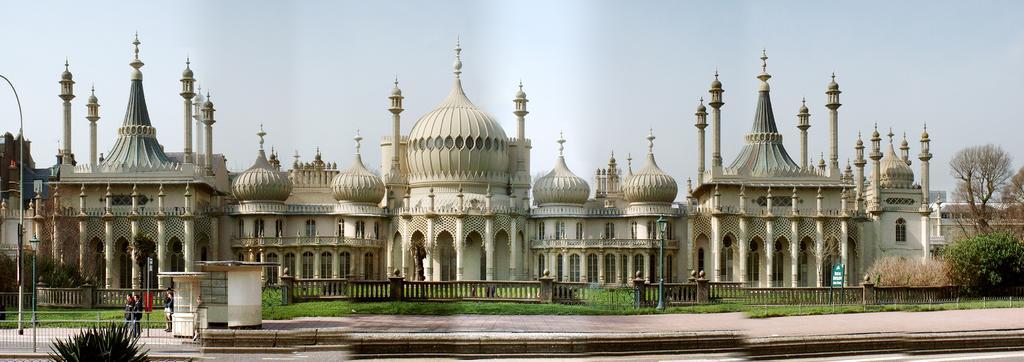Please provide a concise description of this image. In this picture, we see a Royal Pavilion palace. At the bottom of the picture, we see a plant. Behind that, we see three men are standing near the gate. On the left side, we see a pole and railing. We see the grass. We see the poles and railing in the middle of the picture. On the right side, there are trees. At the top of the picture, we see the sky. 